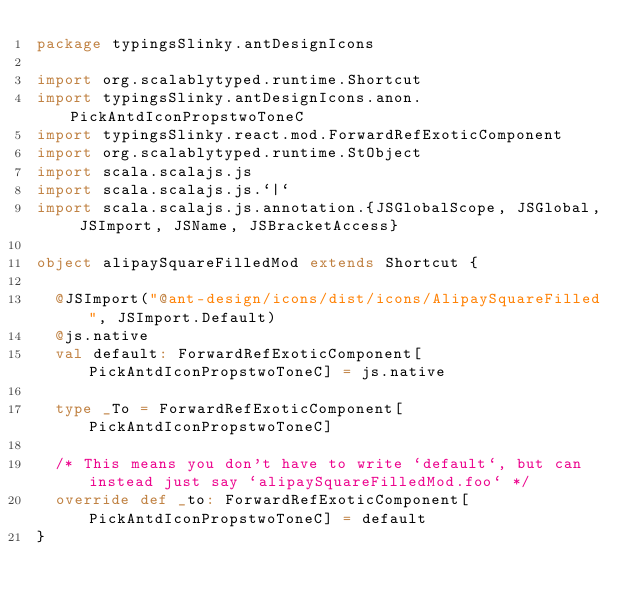<code> <loc_0><loc_0><loc_500><loc_500><_Scala_>package typingsSlinky.antDesignIcons

import org.scalablytyped.runtime.Shortcut
import typingsSlinky.antDesignIcons.anon.PickAntdIconPropstwoToneC
import typingsSlinky.react.mod.ForwardRefExoticComponent
import org.scalablytyped.runtime.StObject
import scala.scalajs.js
import scala.scalajs.js.`|`
import scala.scalajs.js.annotation.{JSGlobalScope, JSGlobal, JSImport, JSName, JSBracketAccess}

object alipaySquareFilledMod extends Shortcut {
  
  @JSImport("@ant-design/icons/dist/icons/AlipaySquareFilled", JSImport.Default)
  @js.native
  val default: ForwardRefExoticComponent[PickAntdIconPropstwoToneC] = js.native
  
  type _To = ForwardRefExoticComponent[PickAntdIconPropstwoToneC]
  
  /* This means you don't have to write `default`, but can instead just say `alipaySquareFilledMod.foo` */
  override def _to: ForwardRefExoticComponent[PickAntdIconPropstwoToneC] = default
}
</code> 